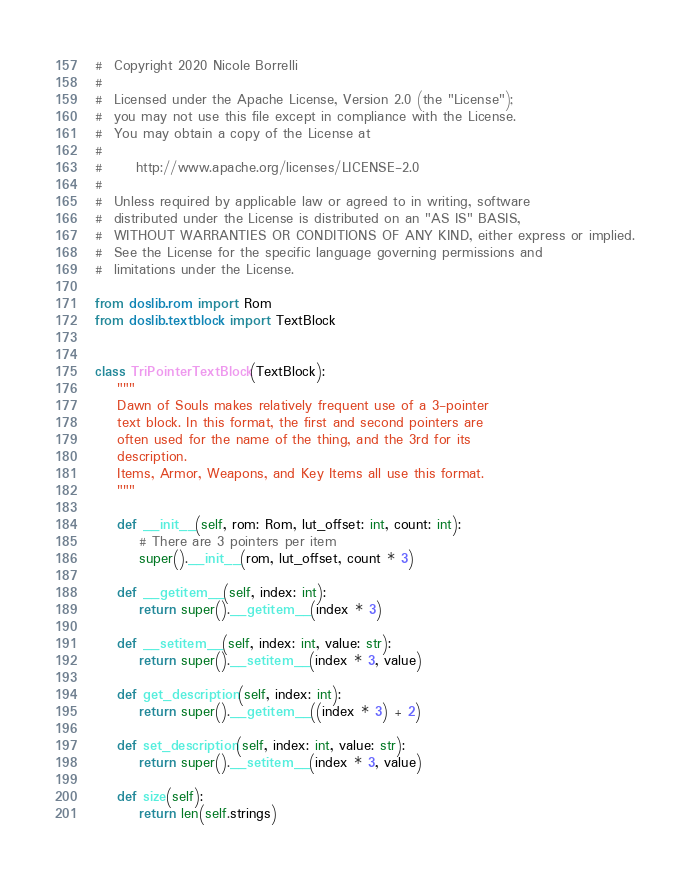<code> <loc_0><loc_0><loc_500><loc_500><_Python_>#  Copyright 2020 Nicole Borrelli
#
#  Licensed under the Apache License, Version 2.0 (the "License");
#  you may not use this file except in compliance with the License.
#  You may obtain a copy of the License at
#
#      http://www.apache.org/licenses/LICENSE-2.0
#
#  Unless required by applicable law or agreed to in writing, software
#  distributed under the License is distributed on an "AS IS" BASIS,
#  WITHOUT WARRANTIES OR CONDITIONS OF ANY KIND, either express or implied.
#  See the License for the specific language governing permissions and
#  limitations under the License.

from doslib.rom import Rom
from doslib.textblock import TextBlock


class TriPointerTextBlock(TextBlock):
    """
    Dawn of Souls makes relatively frequent use of a 3-pointer
    text block. In this format, the first and second pointers are
    often used for the name of the thing, and the 3rd for its
    description.
    Items, Armor, Weapons, and Key Items all use this format.
    """

    def __init__(self, rom: Rom, lut_offset: int, count: int):
        # There are 3 pointers per item
        super().__init__(rom, lut_offset, count * 3)

    def __getitem__(self, index: int):
        return super().__getitem__(index * 3)

    def __setitem__(self, index: int, value: str):
        return super().__setitem__(index * 3, value)

    def get_description(self, index: int):
        return super().__getitem__((index * 3) + 2)

    def set_description(self, index: int, value: str):
        return super().__setitem__(index * 3, value)

    def size(self):
        return len(self.strings)
</code> 